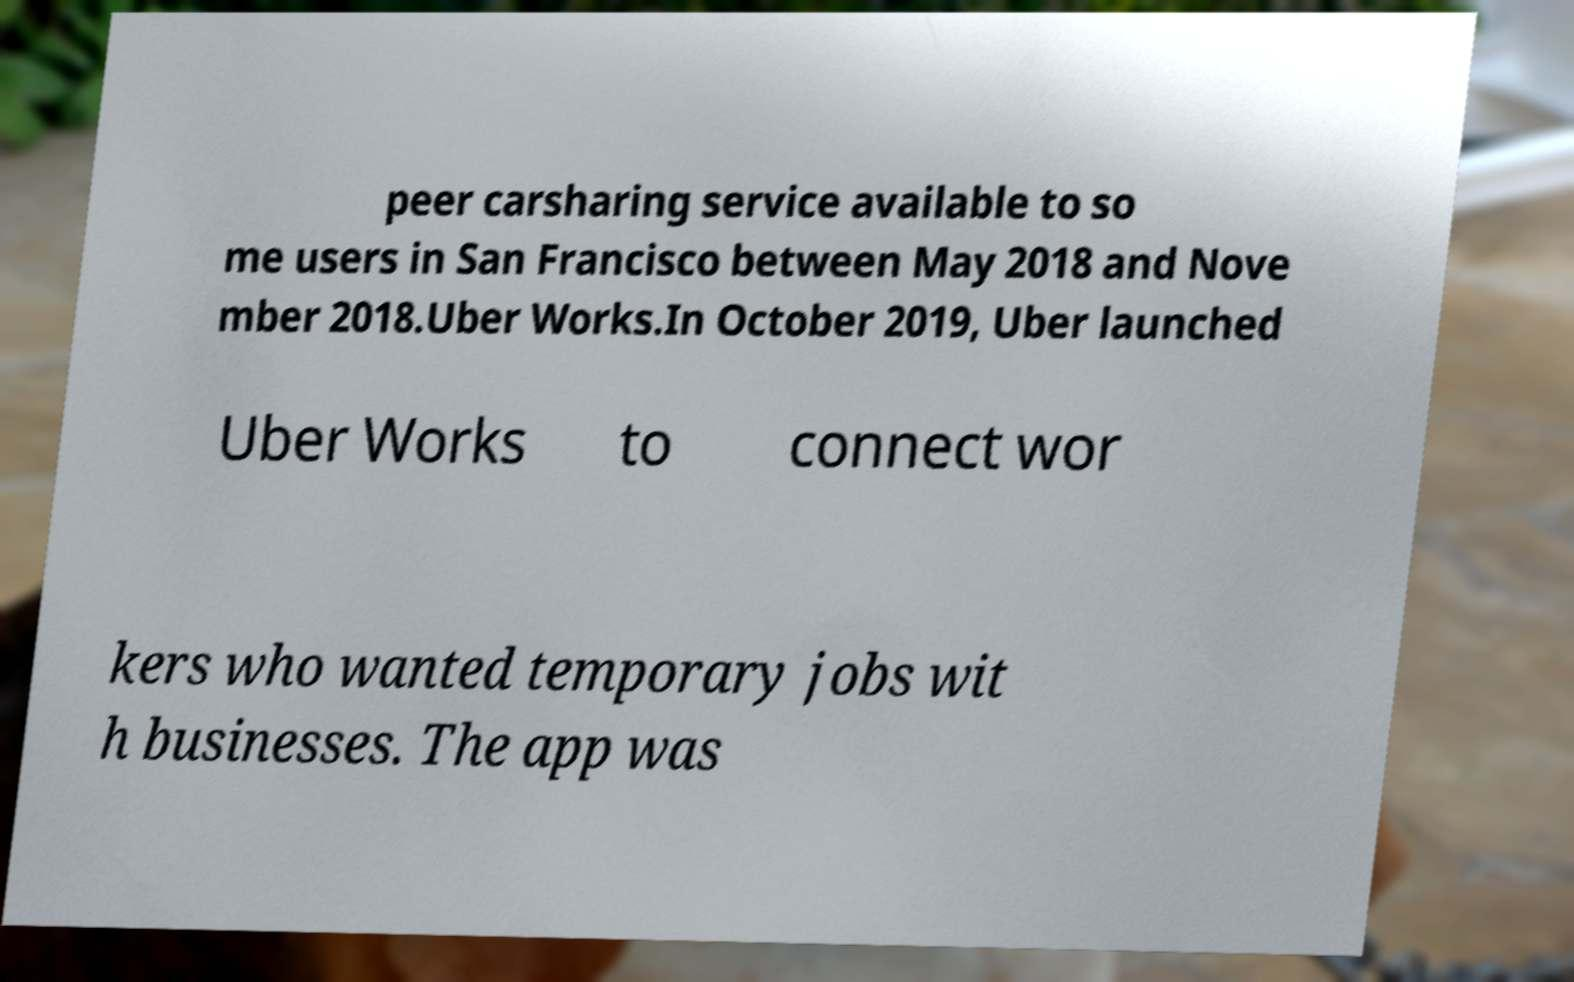There's text embedded in this image that I need extracted. Can you transcribe it verbatim? peer carsharing service available to so me users in San Francisco between May 2018 and Nove mber 2018.Uber Works.In October 2019, Uber launched Uber Works to connect wor kers who wanted temporary jobs wit h businesses. The app was 